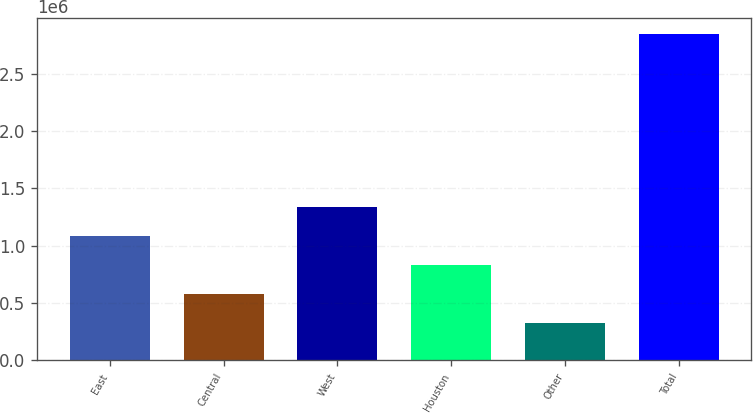Convert chart. <chart><loc_0><loc_0><loc_500><loc_500><bar_chart><fcel>East<fcel>Central<fcel>West<fcel>Houston<fcel>Other<fcel>Total<nl><fcel>1.08416e+06<fcel>580626<fcel>1.33593e+06<fcel>832393<fcel>328858<fcel>2.84653e+06<nl></chart> 